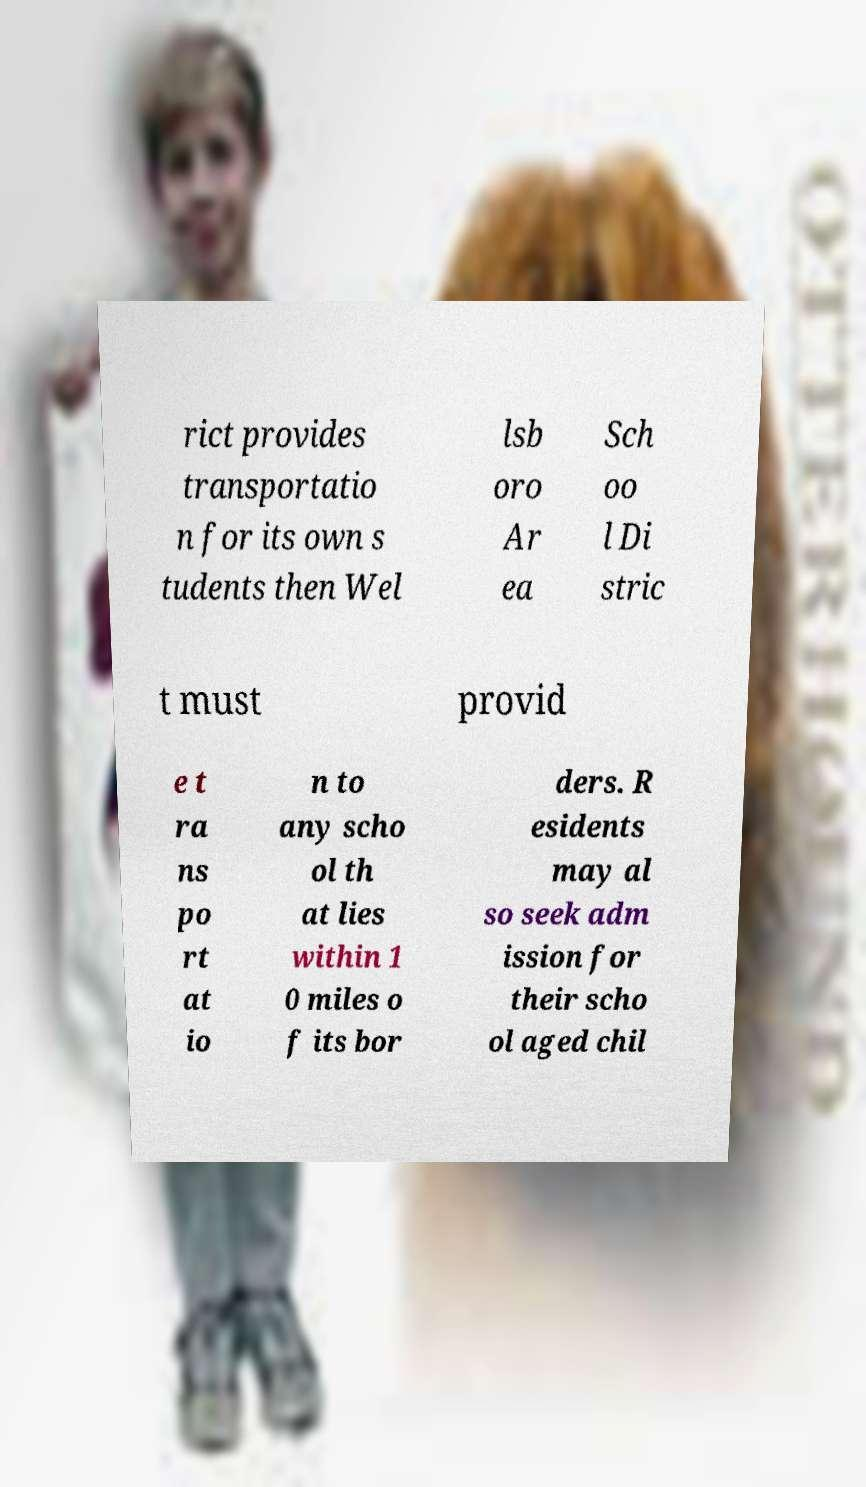Can you accurately transcribe the text from the provided image for me? rict provides transportatio n for its own s tudents then Wel lsb oro Ar ea Sch oo l Di stric t must provid e t ra ns po rt at io n to any scho ol th at lies within 1 0 miles o f its bor ders. R esidents may al so seek adm ission for their scho ol aged chil 